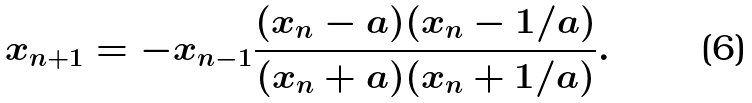Convert formula to latex. <formula><loc_0><loc_0><loc_500><loc_500>x _ { n + 1 } & = - x _ { n - 1 } \frac { ( x _ { n } - a ) ( x _ { n } - 1 / a ) } { ( x _ { n } + a ) ( x _ { n } + 1 / a ) } .</formula> 